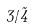<formula> <loc_0><loc_0><loc_500><loc_500>3 / \tilde { 4 }</formula> 